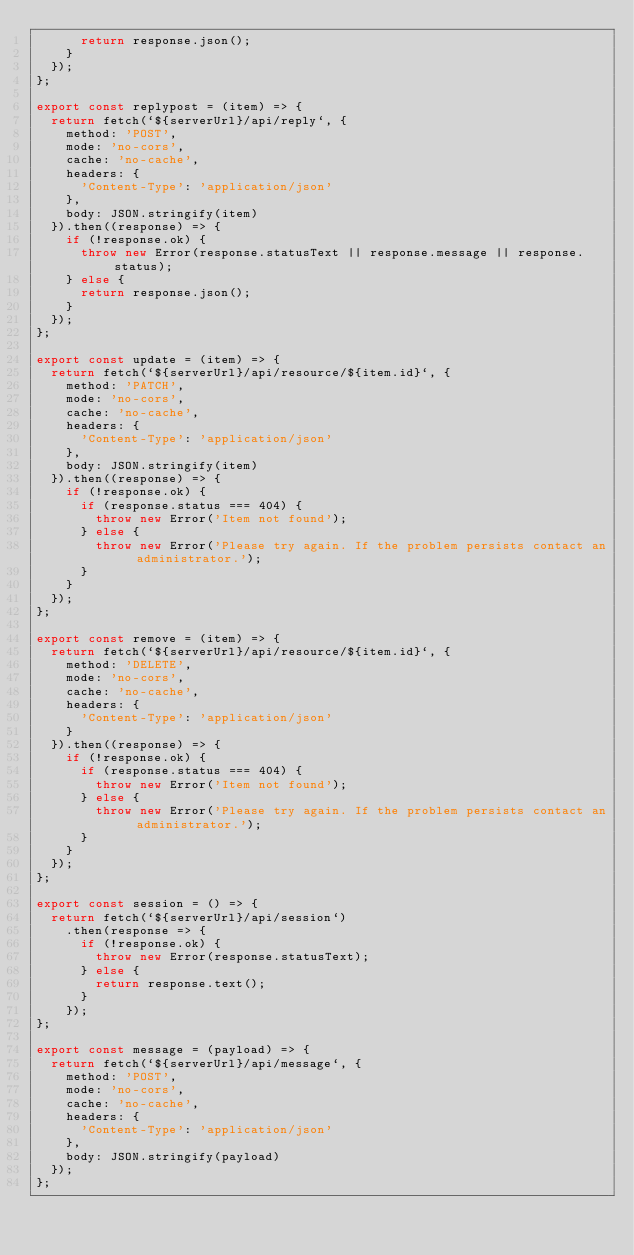Convert code to text. <code><loc_0><loc_0><loc_500><loc_500><_JavaScript_>      return response.json();
    }
  });
};

export const replypost = (item) => {
  return fetch(`${serverUrl}/api/reply`, {
    method: 'POST',
    mode: 'no-cors',
    cache: 'no-cache',
    headers: {
      'Content-Type': 'application/json'
    },
    body: JSON.stringify(item)
  }).then((response) => {
    if (!response.ok) {
      throw new Error(response.statusText || response.message || response.status);
    } else {
      return response.json();
    }
  });
};

export const update = (item) => {
  return fetch(`${serverUrl}/api/resource/${item.id}`, {
    method: 'PATCH',
    mode: 'no-cors',
    cache: 'no-cache',
    headers: {
      'Content-Type': 'application/json'
    },
    body: JSON.stringify(item)
  }).then((response) => {
    if (!response.ok) {
      if (response.status === 404) {
        throw new Error('Item not found');
      } else {
        throw new Error('Please try again. If the problem persists contact an administrator.');
      }
    }
  });
};

export const remove = (item) => {
  return fetch(`${serverUrl}/api/resource/${item.id}`, {
    method: 'DELETE',
    mode: 'no-cors',
    cache: 'no-cache',
    headers: {
      'Content-Type': 'application/json'
    }
  }).then((response) => {
    if (!response.ok) {
      if (response.status === 404) {
        throw new Error('Item not found');
      } else {
        throw new Error('Please try again. If the problem persists contact an administrator.');
      }
    }
  });
};

export const session = () => {
  return fetch(`${serverUrl}/api/session`)
    .then(response => {
      if (!response.ok) {
        throw new Error(response.statusText);
      } else {
        return response.text();
      }
    });
};

export const message = (payload) => {
  return fetch(`${serverUrl}/api/message`, {
    method: 'POST',
    mode: 'no-cors',
    cache: 'no-cache',
    headers: {
      'Content-Type': 'application/json'
    },
    body: JSON.stringify(payload)
  });
};
</code> 